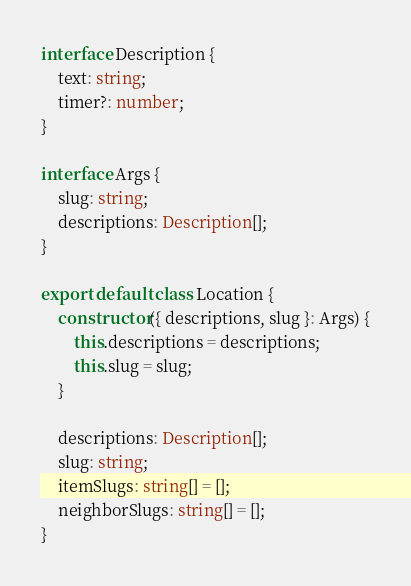Convert code to text. <code><loc_0><loc_0><loc_500><loc_500><_TypeScript_>interface Description {
	text: string;
	timer?: number;
}

interface Args {
	slug: string;
	descriptions: Description[];
}

export default class Location {
	constructor({ descriptions, slug }: Args) {
		this.descriptions = descriptions;
		this.slug = slug;
	}

	descriptions: Description[];
	slug: string;
	itemSlugs: string[] = [];
	neighborSlugs: string[] = [];
}
</code> 